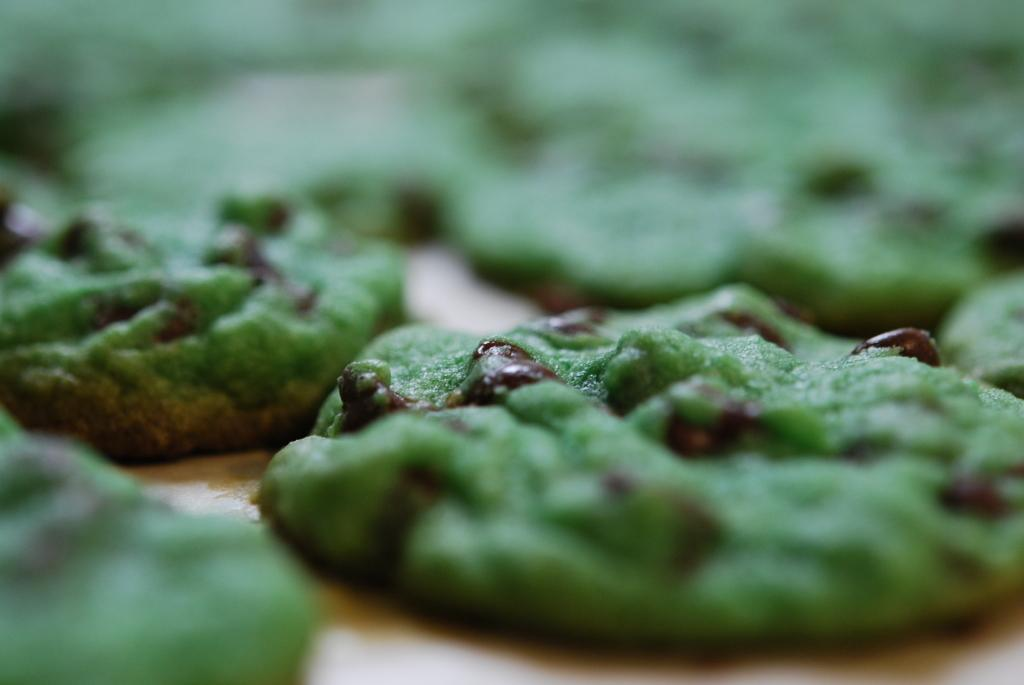What types of items can be seen in the image? There are food items in the image. On what surface are the food items placed? The food items are on a wooden surface. Is there a beggar asking for food in the image? There is no beggar present in the image. Are there any giants in the image? There are no giants present in the image. 